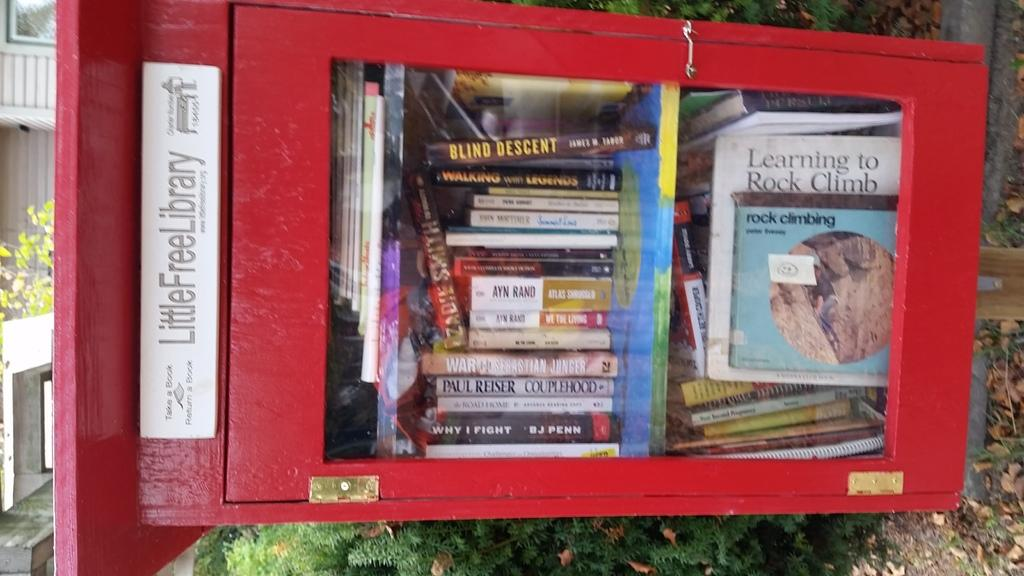<image>
Relay a brief, clear account of the picture shown. A little free library includes a book called Blind Descent. 